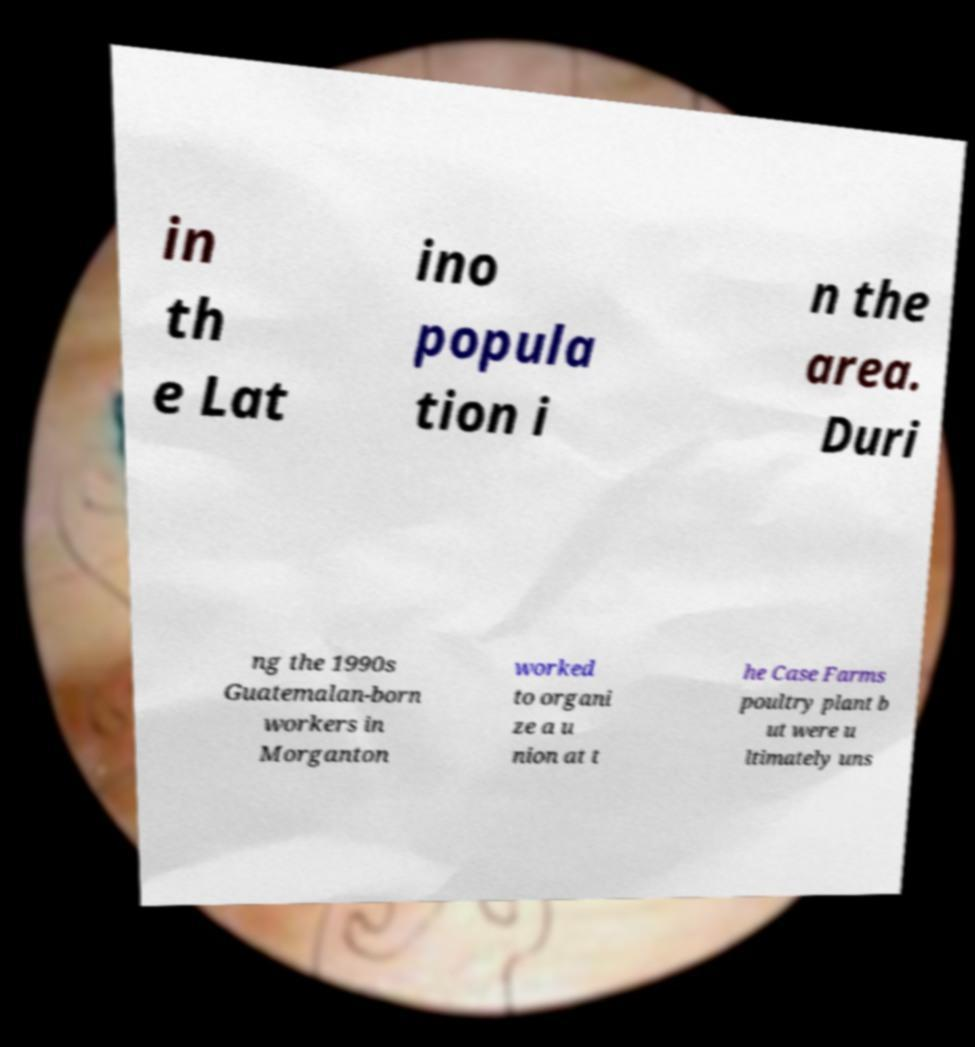Could you assist in decoding the text presented in this image and type it out clearly? in th e Lat ino popula tion i n the area. Duri ng the 1990s Guatemalan-born workers in Morganton worked to organi ze a u nion at t he Case Farms poultry plant b ut were u ltimately uns 